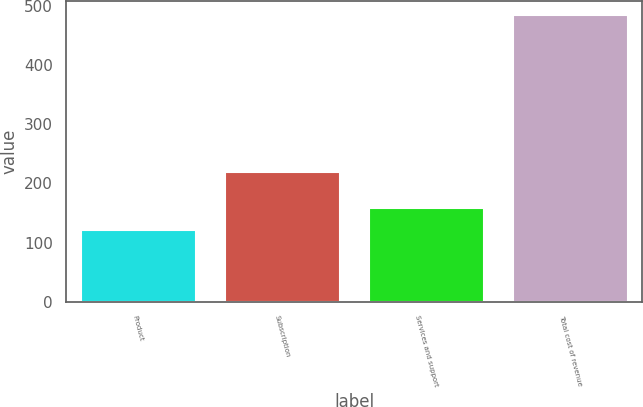Convert chart. <chart><loc_0><loc_0><loc_500><loc_500><bar_chart><fcel>Product<fcel>Subscription<fcel>Services and support<fcel>Total cost of revenue<nl><fcel>121.7<fcel>219.1<fcel>157.91<fcel>483.8<nl></chart> 